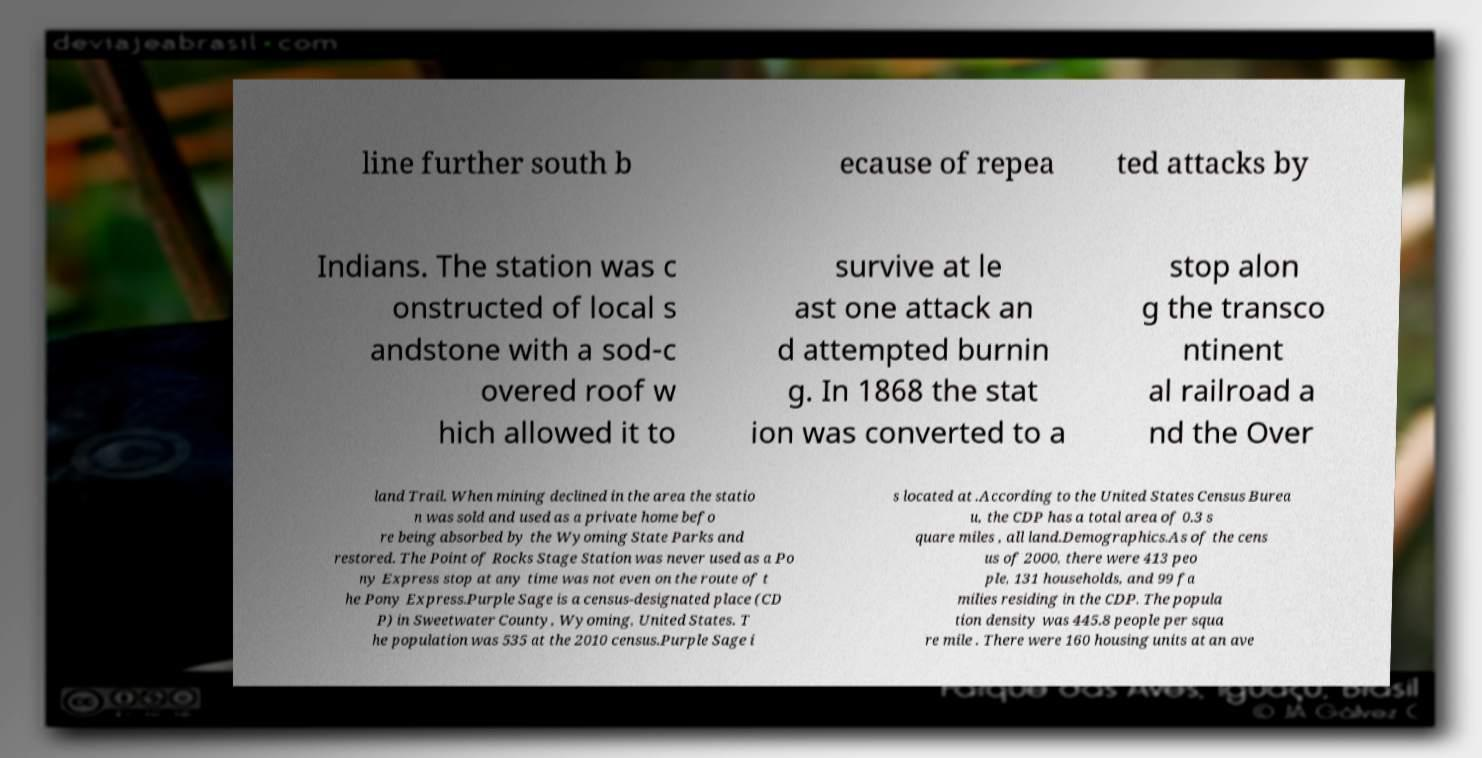Please identify and transcribe the text found in this image. line further south b ecause of repea ted attacks by Indians. The station was c onstructed of local s andstone with a sod-c overed roof w hich allowed it to survive at le ast one attack an d attempted burnin g. In 1868 the stat ion was converted to a stop alon g the transco ntinent al railroad a nd the Over land Trail. When mining declined in the area the statio n was sold and used as a private home befo re being absorbed by the Wyoming State Parks and restored. The Point of Rocks Stage Station was never used as a Po ny Express stop at any time was not even on the route of t he Pony Express.Purple Sage is a census-designated place (CD P) in Sweetwater County, Wyoming, United States. T he population was 535 at the 2010 census.Purple Sage i s located at .According to the United States Census Burea u, the CDP has a total area of 0.3 s quare miles , all land.Demographics.As of the cens us of 2000, there were 413 peo ple, 131 households, and 99 fa milies residing in the CDP. The popula tion density was 445.8 people per squa re mile . There were 160 housing units at an ave 